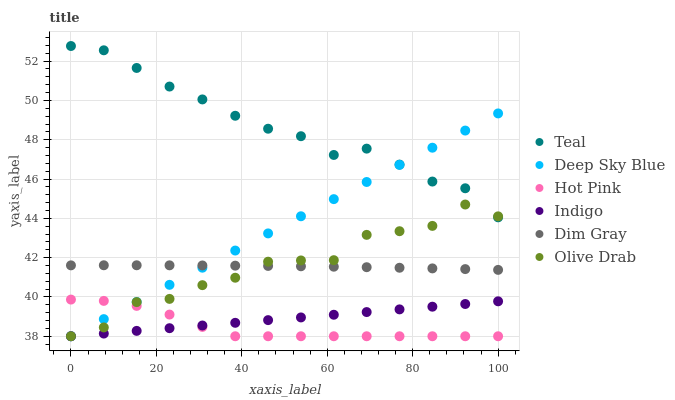Does Hot Pink have the minimum area under the curve?
Answer yes or no. Yes. Does Teal have the maximum area under the curve?
Answer yes or no. Yes. Does Indigo have the minimum area under the curve?
Answer yes or no. No. Does Indigo have the maximum area under the curve?
Answer yes or no. No. Is Indigo the smoothest?
Answer yes or no. Yes. Is Olive Drab the roughest?
Answer yes or no. Yes. Is Teal the smoothest?
Answer yes or no. No. Is Teal the roughest?
Answer yes or no. No. Does Indigo have the lowest value?
Answer yes or no. Yes. Does Teal have the lowest value?
Answer yes or no. No. Does Teal have the highest value?
Answer yes or no. Yes. Does Indigo have the highest value?
Answer yes or no. No. Is Hot Pink less than Teal?
Answer yes or no. Yes. Is Teal greater than Dim Gray?
Answer yes or no. Yes. Does Indigo intersect Hot Pink?
Answer yes or no. Yes. Is Indigo less than Hot Pink?
Answer yes or no. No. Is Indigo greater than Hot Pink?
Answer yes or no. No. Does Hot Pink intersect Teal?
Answer yes or no. No. 